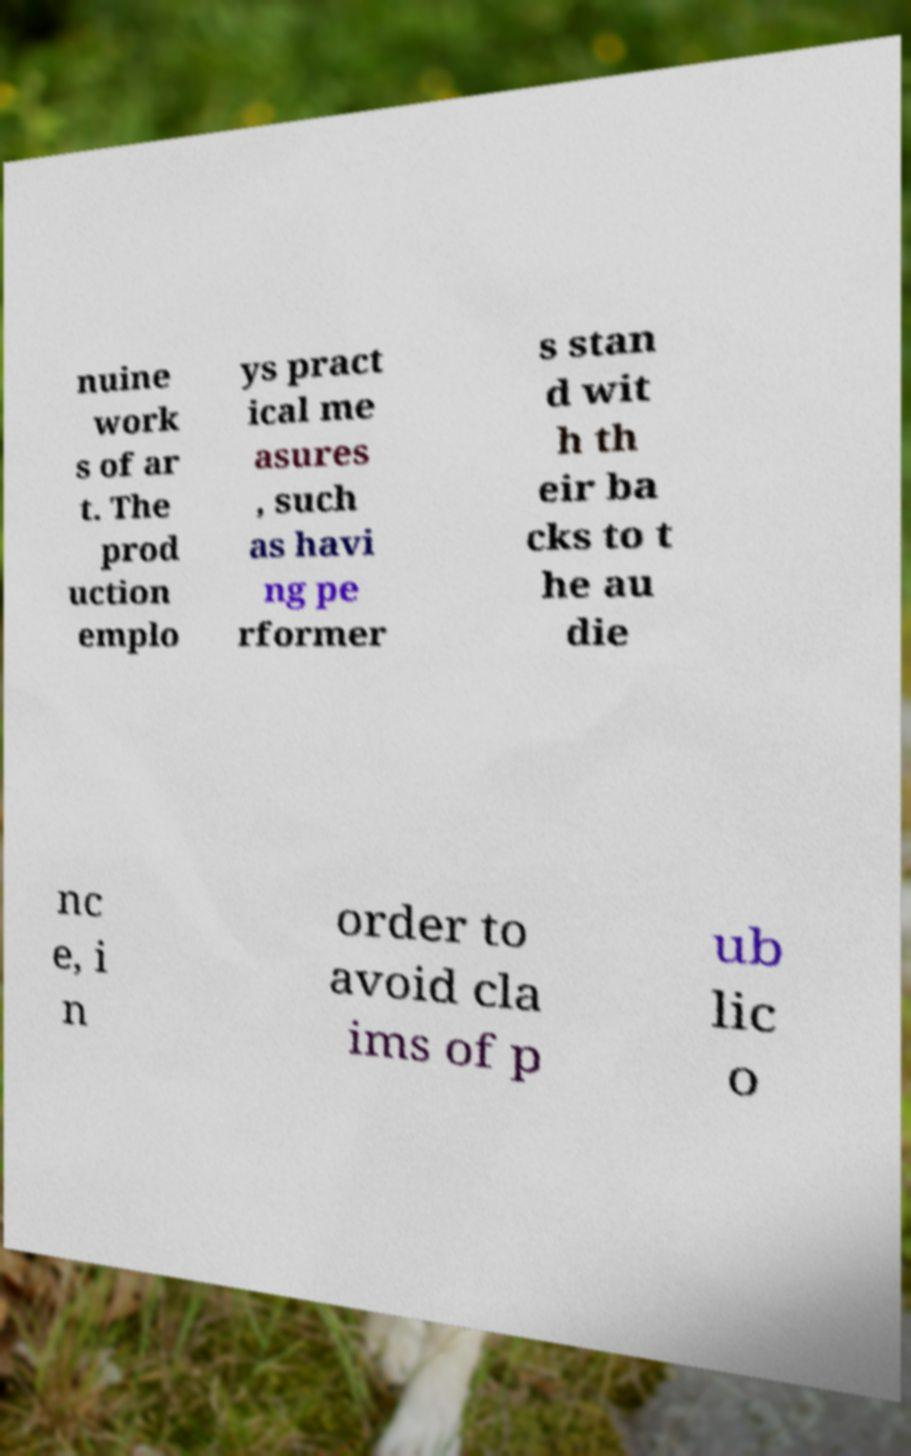Please identify and transcribe the text found in this image. nuine work s of ar t. The prod uction emplo ys pract ical me asures , such as havi ng pe rformer s stan d wit h th eir ba cks to t he au die nc e, i n order to avoid cla ims of p ub lic o 